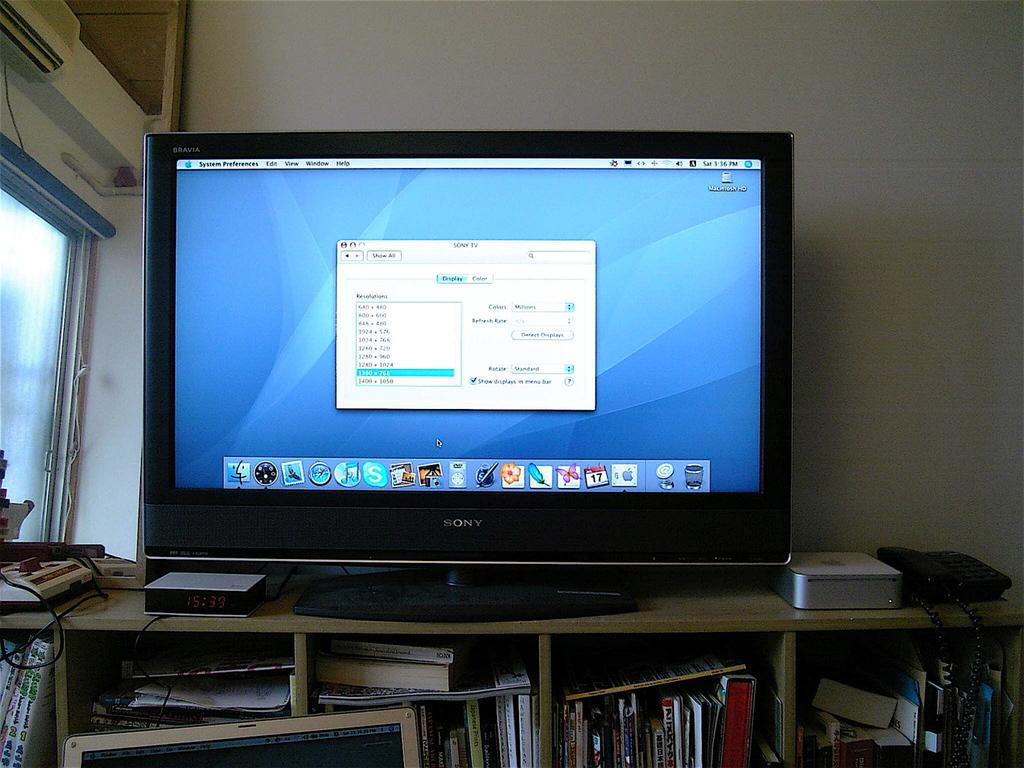<image>
Summarize the visual content of the image. A large monitor is on a cabinet and it is showing screen resolution settings. 